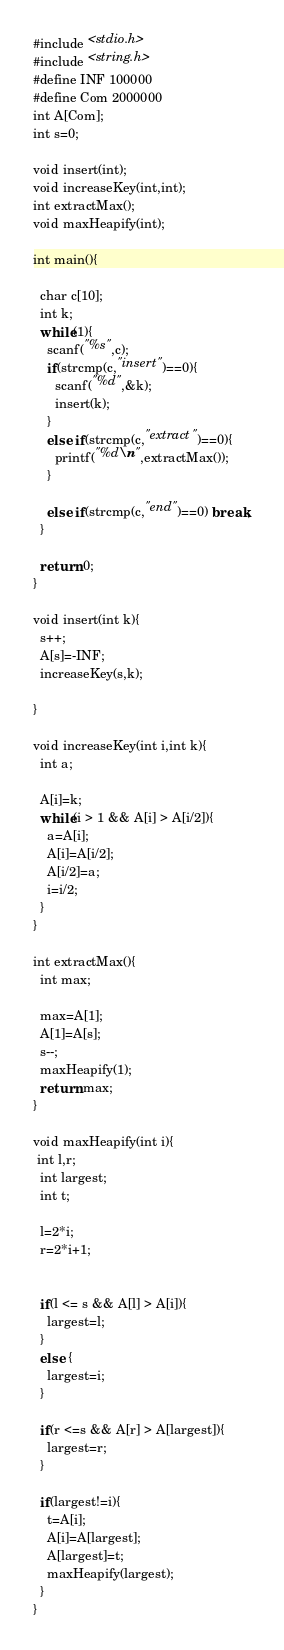<code> <loc_0><loc_0><loc_500><loc_500><_C_>#include <stdio.h>
#include <string.h>
#define INF 100000
#define Com 2000000
int A[Com];
int s=0;

void insert(int);
void increaseKey(int,int);
int extractMax();
void maxHeapify(int);

int main(){

  char c[10];
  int k;
  while(1){
    scanf("%s",c);
    if(strcmp(c,"insert")==0){
      scanf("%d",&k);
      insert(k);
    }
    else if(strcmp(c,"extract")==0){
      printf("%d\n",extractMax());
    }

    else if(strcmp(c,"end")==0) break;
  }

  return 0;
}

void insert(int k){
  s++;
  A[s]=-INF;
  increaseKey(s,k);
 
}

void increaseKey(int i,int k){
  int a;

  A[i]=k;
  while(i > 1 && A[i] > A[i/2]){
    a=A[i];
    A[i]=A[i/2];
    A[i/2]=a;
    i=i/2;
  }
}

int extractMax(){
  int max;

  max=A[1];
  A[1]=A[s];
  s--;
  maxHeapify(1);
  return max;
}

void maxHeapify(int i){
 int l,r;
  int largest;
  int t;

  l=2*i;
  r=2*i+1;


  if(l <= s && A[l] > A[i]){
    largest=l;
  }
  else {
    largest=i;
  }

  if(r <=s && A[r] > A[largest]){
    largest=r;
  }

  if(largest!=i){
    t=A[i];
    A[i]=A[largest];
    A[largest]=t;
    maxHeapify(largest);
  }
}</code> 